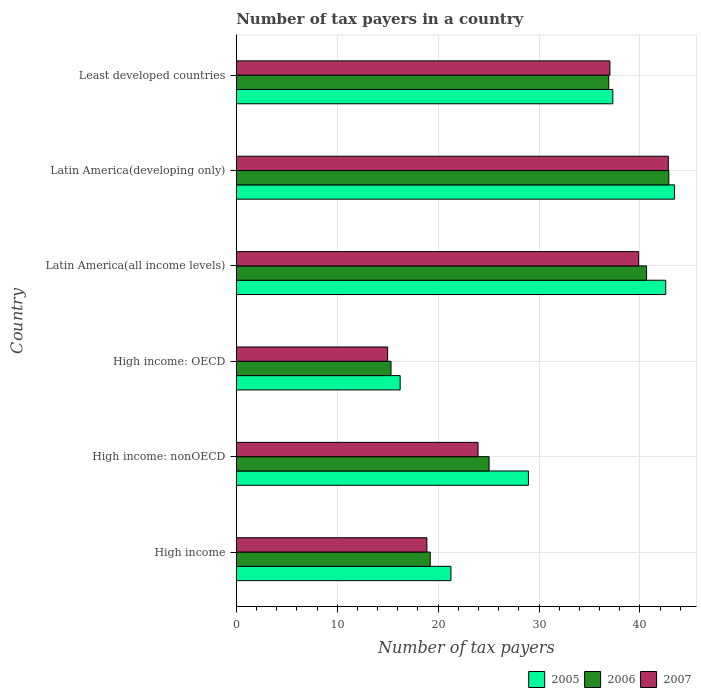How many groups of bars are there?
Make the answer very short. 6. Are the number of bars per tick equal to the number of legend labels?
Give a very brief answer. Yes. Are the number of bars on each tick of the Y-axis equal?
Your answer should be compact. Yes. What is the label of the 2nd group of bars from the top?
Your answer should be very brief. Latin America(developing only). In how many cases, is the number of bars for a given country not equal to the number of legend labels?
Provide a succinct answer. 0. What is the number of tax payers in in 2006 in High income: nonOECD?
Give a very brief answer. 25.05. Across all countries, what is the maximum number of tax payers in in 2005?
Provide a short and direct response. 43.43. Across all countries, what is the minimum number of tax payers in in 2005?
Provide a succinct answer. 16.24. In which country was the number of tax payers in in 2005 maximum?
Your answer should be compact. Latin America(developing only). In which country was the number of tax payers in in 2007 minimum?
Your answer should be very brief. High income: OECD. What is the total number of tax payers in in 2007 in the graph?
Ensure brevity in your answer.  177.54. What is the difference between the number of tax payers in in 2006 in High income: nonOECD and that in Latin America(all income levels)?
Make the answer very short. -15.61. What is the difference between the number of tax payers in in 2005 in Latin America(all income levels) and the number of tax payers in in 2006 in Least developed countries?
Your response must be concise. 5.64. What is the average number of tax payers in in 2006 per country?
Provide a short and direct response. 30. What is the difference between the number of tax payers in in 2005 and number of tax payers in in 2007 in High income: OECD?
Your answer should be very brief. 1.24. In how many countries, is the number of tax payers in in 2005 greater than 30 ?
Your answer should be very brief. 3. What is the ratio of the number of tax payers in in 2005 in High income to that in Least developed countries?
Ensure brevity in your answer.  0.57. What is the difference between the highest and the second highest number of tax payers in in 2005?
Offer a terse response. 0.88. What is the difference between the highest and the lowest number of tax payers in in 2006?
Keep it short and to the point. 27.52. Is the sum of the number of tax payers in in 2005 in High income and Latin America(all income levels) greater than the maximum number of tax payers in in 2007 across all countries?
Your answer should be compact. Yes. What does the 1st bar from the bottom in Latin America(all income levels) represents?
Offer a terse response. 2005. Is it the case that in every country, the sum of the number of tax payers in in 2006 and number of tax payers in in 2007 is greater than the number of tax payers in in 2005?
Make the answer very short. Yes. How many bars are there?
Keep it short and to the point. 18. Are all the bars in the graph horizontal?
Make the answer very short. Yes. How many countries are there in the graph?
Offer a very short reply. 6. Are the values on the major ticks of X-axis written in scientific E-notation?
Offer a very short reply. No. Where does the legend appear in the graph?
Give a very brief answer. Bottom right. How many legend labels are there?
Offer a terse response. 3. How are the legend labels stacked?
Make the answer very short. Horizontal. What is the title of the graph?
Give a very brief answer. Number of tax payers in a country. Does "1964" appear as one of the legend labels in the graph?
Provide a short and direct response. No. What is the label or title of the X-axis?
Offer a terse response. Number of tax payers. What is the Number of tax payers of 2005 in High income?
Your answer should be compact. 21.27. What is the Number of tax payers in 2006 in High income?
Your answer should be very brief. 19.22. What is the Number of tax payers of 2007 in High income?
Offer a terse response. 18.89. What is the Number of tax payers in 2005 in High income: nonOECD?
Offer a terse response. 28.95. What is the Number of tax payers of 2006 in High income: nonOECD?
Provide a short and direct response. 25.05. What is the Number of tax payers of 2007 in High income: nonOECD?
Make the answer very short. 23.96. What is the Number of tax payers of 2005 in High income: OECD?
Make the answer very short. 16.24. What is the Number of tax payers of 2006 in High income: OECD?
Your answer should be very brief. 15.33. What is the Number of tax payers of 2005 in Latin America(all income levels)?
Your answer should be very brief. 42.55. What is the Number of tax payers in 2006 in Latin America(all income levels)?
Ensure brevity in your answer.  40.66. What is the Number of tax payers of 2007 in Latin America(all income levels)?
Provide a short and direct response. 39.87. What is the Number of tax payers of 2005 in Latin America(developing only)?
Your answer should be very brief. 43.43. What is the Number of tax payers in 2006 in Latin America(developing only)?
Ensure brevity in your answer.  42.86. What is the Number of tax payers in 2007 in Latin America(developing only)?
Your answer should be compact. 42.81. What is the Number of tax payers in 2005 in Least developed countries?
Keep it short and to the point. 37.31. What is the Number of tax payers of 2006 in Least developed countries?
Offer a very short reply. 36.91. What is the Number of tax payers in 2007 in Least developed countries?
Offer a very short reply. 37.02. Across all countries, what is the maximum Number of tax payers in 2005?
Make the answer very short. 43.43. Across all countries, what is the maximum Number of tax payers in 2006?
Ensure brevity in your answer.  42.86. Across all countries, what is the maximum Number of tax payers in 2007?
Keep it short and to the point. 42.81. Across all countries, what is the minimum Number of tax payers in 2005?
Your answer should be compact. 16.24. Across all countries, what is the minimum Number of tax payers in 2006?
Your answer should be compact. 15.33. Across all countries, what is the minimum Number of tax payers of 2007?
Give a very brief answer. 15. What is the total Number of tax payers of 2005 in the graph?
Ensure brevity in your answer.  189.75. What is the total Number of tax payers in 2006 in the graph?
Offer a terse response. 180.02. What is the total Number of tax payers of 2007 in the graph?
Your answer should be very brief. 177.54. What is the difference between the Number of tax payers of 2005 in High income and that in High income: nonOECD?
Provide a succinct answer. -7.68. What is the difference between the Number of tax payers of 2006 in High income and that in High income: nonOECD?
Provide a succinct answer. -5.83. What is the difference between the Number of tax payers in 2007 in High income and that in High income: nonOECD?
Give a very brief answer. -5.07. What is the difference between the Number of tax payers of 2005 in High income and that in High income: OECD?
Ensure brevity in your answer.  5.03. What is the difference between the Number of tax payers in 2006 in High income and that in High income: OECD?
Your answer should be very brief. 3.89. What is the difference between the Number of tax payers of 2007 in High income and that in High income: OECD?
Give a very brief answer. 3.89. What is the difference between the Number of tax payers of 2005 in High income and that in Latin America(all income levels)?
Ensure brevity in your answer.  -21.28. What is the difference between the Number of tax payers in 2006 in High income and that in Latin America(all income levels)?
Offer a terse response. -21.44. What is the difference between the Number of tax payers in 2007 in High income and that in Latin America(all income levels)?
Your answer should be very brief. -20.98. What is the difference between the Number of tax payers of 2005 in High income and that in Latin America(developing only)?
Keep it short and to the point. -22.16. What is the difference between the Number of tax payers in 2006 in High income and that in Latin America(developing only)?
Your answer should be very brief. -23.64. What is the difference between the Number of tax payers of 2007 in High income and that in Latin America(developing only)?
Give a very brief answer. -23.92. What is the difference between the Number of tax payers of 2005 in High income and that in Least developed countries?
Keep it short and to the point. -16.04. What is the difference between the Number of tax payers in 2006 in High income and that in Least developed countries?
Provide a short and direct response. -17.69. What is the difference between the Number of tax payers in 2007 in High income and that in Least developed countries?
Keep it short and to the point. -18.14. What is the difference between the Number of tax payers of 2005 in High income: nonOECD and that in High income: OECD?
Offer a terse response. 12.71. What is the difference between the Number of tax payers of 2006 in High income: nonOECD and that in High income: OECD?
Your answer should be very brief. 9.72. What is the difference between the Number of tax payers of 2007 in High income: nonOECD and that in High income: OECD?
Your response must be concise. 8.96. What is the difference between the Number of tax payers in 2005 in High income: nonOECD and that in Latin America(all income levels)?
Keep it short and to the point. -13.6. What is the difference between the Number of tax payers of 2006 in High income: nonOECD and that in Latin America(all income levels)?
Provide a succinct answer. -15.61. What is the difference between the Number of tax payers of 2007 in High income: nonOECD and that in Latin America(all income levels)?
Provide a succinct answer. -15.91. What is the difference between the Number of tax payers in 2005 in High income: nonOECD and that in Latin America(developing only)?
Your response must be concise. -14.48. What is the difference between the Number of tax payers in 2006 in High income: nonOECD and that in Latin America(developing only)?
Make the answer very short. -17.81. What is the difference between the Number of tax payers in 2007 in High income: nonOECD and that in Latin America(developing only)?
Give a very brief answer. -18.85. What is the difference between the Number of tax payers of 2005 in High income: nonOECD and that in Least developed countries?
Offer a very short reply. -8.36. What is the difference between the Number of tax payers of 2006 in High income: nonOECD and that in Least developed countries?
Your answer should be compact. -11.86. What is the difference between the Number of tax payers in 2007 in High income: nonOECD and that in Least developed countries?
Give a very brief answer. -13.07. What is the difference between the Number of tax payers of 2005 in High income: OECD and that in Latin America(all income levels)?
Provide a succinct answer. -26.31. What is the difference between the Number of tax payers of 2006 in High income: OECD and that in Latin America(all income levels)?
Your response must be concise. -25.32. What is the difference between the Number of tax payers in 2007 in High income: OECD and that in Latin America(all income levels)?
Provide a succinct answer. -24.87. What is the difference between the Number of tax payers in 2005 in High income: OECD and that in Latin America(developing only)?
Ensure brevity in your answer.  -27.19. What is the difference between the Number of tax payers in 2006 in High income: OECD and that in Latin America(developing only)?
Your answer should be very brief. -27.52. What is the difference between the Number of tax payers of 2007 in High income: OECD and that in Latin America(developing only)?
Your response must be concise. -27.81. What is the difference between the Number of tax payers in 2005 in High income: OECD and that in Least developed countries?
Ensure brevity in your answer.  -21.07. What is the difference between the Number of tax payers of 2006 in High income: OECD and that in Least developed countries?
Offer a very short reply. -21.57. What is the difference between the Number of tax payers of 2007 in High income: OECD and that in Least developed countries?
Provide a succinct answer. -22.02. What is the difference between the Number of tax payers of 2005 in Latin America(all income levels) and that in Latin America(developing only)?
Offer a terse response. -0.88. What is the difference between the Number of tax payers of 2006 in Latin America(all income levels) and that in Latin America(developing only)?
Give a very brief answer. -2.2. What is the difference between the Number of tax payers of 2007 in Latin America(all income levels) and that in Latin America(developing only)?
Offer a terse response. -2.94. What is the difference between the Number of tax payers of 2005 in Latin America(all income levels) and that in Least developed countries?
Provide a short and direct response. 5.24. What is the difference between the Number of tax payers in 2006 in Latin America(all income levels) and that in Least developed countries?
Ensure brevity in your answer.  3.75. What is the difference between the Number of tax payers of 2007 in Latin America(all income levels) and that in Least developed countries?
Offer a very short reply. 2.84. What is the difference between the Number of tax payers of 2005 in Latin America(developing only) and that in Least developed countries?
Keep it short and to the point. 6.12. What is the difference between the Number of tax payers of 2006 in Latin America(developing only) and that in Least developed countries?
Provide a succinct answer. 5.95. What is the difference between the Number of tax payers in 2007 in Latin America(developing only) and that in Least developed countries?
Offer a terse response. 5.79. What is the difference between the Number of tax payers of 2005 in High income and the Number of tax payers of 2006 in High income: nonOECD?
Offer a terse response. -3.78. What is the difference between the Number of tax payers of 2005 in High income and the Number of tax payers of 2007 in High income: nonOECD?
Make the answer very short. -2.69. What is the difference between the Number of tax payers of 2006 in High income and the Number of tax payers of 2007 in High income: nonOECD?
Make the answer very short. -4.74. What is the difference between the Number of tax payers of 2005 in High income and the Number of tax payers of 2006 in High income: OECD?
Ensure brevity in your answer.  5.94. What is the difference between the Number of tax payers of 2005 in High income and the Number of tax payers of 2007 in High income: OECD?
Offer a terse response. 6.27. What is the difference between the Number of tax payers of 2006 in High income and the Number of tax payers of 2007 in High income: OECD?
Keep it short and to the point. 4.22. What is the difference between the Number of tax payers of 2005 in High income and the Number of tax payers of 2006 in Latin America(all income levels)?
Give a very brief answer. -19.38. What is the difference between the Number of tax payers of 2005 in High income and the Number of tax payers of 2007 in Latin America(all income levels)?
Provide a succinct answer. -18.6. What is the difference between the Number of tax payers of 2006 in High income and the Number of tax payers of 2007 in Latin America(all income levels)?
Keep it short and to the point. -20.65. What is the difference between the Number of tax payers of 2005 in High income and the Number of tax payers of 2006 in Latin America(developing only)?
Provide a succinct answer. -21.59. What is the difference between the Number of tax payers in 2005 in High income and the Number of tax payers in 2007 in Latin America(developing only)?
Your answer should be compact. -21.54. What is the difference between the Number of tax payers of 2006 in High income and the Number of tax payers of 2007 in Latin America(developing only)?
Provide a succinct answer. -23.59. What is the difference between the Number of tax payers in 2005 in High income and the Number of tax payers in 2006 in Least developed countries?
Make the answer very short. -15.64. What is the difference between the Number of tax payers of 2005 in High income and the Number of tax payers of 2007 in Least developed countries?
Keep it short and to the point. -15.75. What is the difference between the Number of tax payers in 2006 in High income and the Number of tax payers in 2007 in Least developed countries?
Your answer should be compact. -17.8. What is the difference between the Number of tax payers in 2005 in High income: nonOECD and the Number of tax payers in 2006 in High income: OECD?
Provide a short and direct response. 13.61. What is the difference between the Number of tax payers in 2005 in High income: nonOECD and the Number of tax payers in 2007 in High income: OECD?
Make the answer very short. 13.95. What is the difference between the Number of tax payers of 2006 in High income: nonOECD and the Number of tax payers of 2007 in High income: OECD?
Offer a terse response. 10.05. What is the difference between the Number of tax payers of 2005 in High income: nonOECD and the Number of tax payers of 2006 in Latin America(all income levels)?
Provide a short and direct response. -11.71. What is the difference between the Number of tax payers of 2005 in High income: nonOECD and the Number of tax payers of 2007 in Latin America(all income levels)?
Give a very brief answer. -10.92. What is the difference between the Number of tax payers in 2006 in High income: nonOECD and the Number of tax payers in 2007 in Latin America(all income levels)?
Offer a very short reply. -14.82. What is the difference between the Number of tax payers in 2005 in High income: nonOECD and the Number of tax payers in 2006 in Latin America(developing only)?
Ensure brevity in your answer.  -13.91. What is the difference between the Number of tax payers of 2005 in High income: nonOECD and the Number of tax payers of 2007 in Latin America(developing only)?
Offer a very short reply. -13.86. What is the difference between the Number of tax payers of 2006 in High income: nonOECD and the Number of tax payers of 2007 in Latin America(developing only)?
Make the answer very short. -17.76. What is the difference between the Number of tax payers in 2005 in High income: nonOECD and the Number of tax payers in 2006 in Least developed countries?
Provide a short and direct response. -7.96. What is the difference between the Number of tax payers of 2005 in High income: nonOECD and the Number of tax payers of 2007 in Least developed countries?
Provide a short and direct response. -8.08. What is the difference between the Number of tax payers in 2006 in High income: nonOECD and the Number of tax payers in 2007 in Least developed countries?
Your answer should be very brief. -11.97. What is the difference between the Number of tax payers in 2005 in High income: OECD and the Number of tax payers in 2006 in Latin America(all income levels)?
Ensure brevity in your answer.  -24.41. What is the difference between the Number of tax payers in 2005 in High income: OECD and the Number of tax payers in 2007 in Latin America(all income levels)?
Your answer should be compact. -23.63. What is the difference between the Number of tax payers in 2006 in High income: OECD and the Number of tax payers in 2007 in Latin America(all income levels)?
Make the answer very short. -24.53. What is the difference between the Number of tax payers of 2005 in High income: OECD and the Number of tax payers of 2006 in Latin America(developing only)?
Make the answer very short. -26.62. What is the difference between the Number of tax payers in 2005 in High income: OECD and the Number of tax payers in 2007 in Latin America(developing only)?
Keep it short and to the point. -26.57. What is the difference between the Number of tax payers of 2006 in High income: OECD and the Number of tax payers of 2007 in Latin America(developing only)?
Offer a very short reply. -27.48. What is the difference between the Number of tax payers in 2005 in High income: OECD and the Number of tax payers in 2006 in Least developed countries?
Your answer should be very brief. -20.67. What is the difference between the Number of tax payers in 2005 in High income: OECD and the Number of tax payers in 2007 in Least developed countries?
Provide a succinct answer. -20.78. What is the difference between the Number of tax payers in 2006 in High income: OECD and the Number of tax payers in 2007 in Least developed countries?
Give a very brief answer. -21.69. What is the difference between the Number of tax payers of 2005 in Latin America(all income levels) and the Number of tax payers of 2006 in Latin America(developing only)?
Offer a very short reply. -0.31. What is the difference between the Number of tax payers of 2005 in Latin America(all income levels) and the Number of tax payers of 2007 in Latin America(developing only)?
Provide a short and direct response. -0.26. What is the difference between the Number of tax payers of 2006 in Latin America(all income levels) and the Number of tax payers of 2007 in Latin America(developing only)?
Give a very brief answer. -2.15. What is the difference between the Number of tax payers of 2005 in Latin America(all income levels) and the Number of tax payers of 2006 in Least developed countries?
Your answer should be very brief. 5.64. What is the difference between the Number of tax payers of 2005 in Latin America(all income levels) and the Number of tax payers of 2007 in Least developed countries?
Your answer should be compact. 5.53. What is the difference between the Number of tax payers in 2006 in Latin America(all income levels) and the Number of tax payers in 2007 in Least developed countries?
Make the answer very short. 3.63. What is the difference between the Number of tax payers in 2005 in Latin America(developing only) and the Number of tax payers in 2006 in Least developed countries?
Give a very brief answer. 6.52. What is the difference between the Number of tax payers of 2005 in Latin America(developing only) and the Number of tax payers of 2007 in Least developed countries?
Make the answer very short. 6.41. What is the difference between the Number of tax payers in 2006 in Latin America(developing only) and the Number of tax payers in 2007 in Least developed countries?
Keep it short and to the point. 5.83. What is the average Number of tax payers of 2005 per country?
Give a very brief answer. 31.62. What is the average Number of tax payers in 2006 per country?
Ensure brevity in your answer.  30. What is the average Number of tax payers of 2007 per country?
Provide a succinct answer. 29.59. What is the difference between the Number of tax payers of 2005 and Number of tax payers of 2006 in High income?
Provide a succinct answer. 2.05. What is the difference between the Number of tax payers in 2005 and Number of tax payers in 2007 in High income?
Keep it short and to the point. 2.38. What is the difference between the Number of tax payers of 2006 and Number of tax payers of 2007 in High income?
Give a very brief answer. 0.33. What is the difference between the Number of tax payers in 2005 and Number of tax payers in 2006 in High income: nonOECD?
Your answer should be compact. 3.9. What is the difference between the Number of tax payers in 2005 and Number of tax payers in 2007 in High income: nonOECD?
Offer a terse response. 4.99. What is the difference between the Number of tax payers of 2006 and Number of tax payers of 2007 in High income: nonOECD?
Offer a very short reply. 1.09. What is the difference between the Number of tax payers of 2005 and Number of tax payers of 2006 in High income: OECD?
Ensure brevity in your answer.  0.91. What is the difference between the Number of tax payers of 2005 and Number of tax payers of 2007 in High income: OECD?
Offer a terse response. 1.24. What is the difference between the Number of tax payers in 2005 and Number of tax payers in 2006 in Latin America(all income levels)?
Keep it short and to the point. 1.9. What is the difference between the Number of tax payers of 2005 and Number of tax payers of 2007 in Latin America(all income levels)?
Provide a succinct answer. 2.69. What is the difference between the Number of tax payers in 2006 and Number of tax payers in 2007 in Latin America(all income levels)?
Keep it short and to the point. 0.79. What is the difference between the Number of tax payers in 2005 and Number of tax payers in 2006 in Latin America(developing only)?
Give a very brief answer. 0.57. What is the difference between the Number of tax payers of 2005 and Number of tax payers of 2007 in Latin America(developing only)?
Offer a very short reply. 0.62. What is the difference between the Number of tax payers in 2006 and Number of tax payers in 2007 in Latin America(developing only)?
Provide a succinct answer. 0.05. What is the difference between the Number of tax payers in 2005 and Number of tax payers in 2006 in Least developed countries?
Provide a short and direct response. 0.4. What is the difference between the Number of tax payers in 2005 and Number of tax payers in 2007 in Least developed countries?
Provide a short and direct response. 0.29. What is the difference between the Number of tax payers in 2006 and Number of tax payers in 2007 in Least developed countries?
Ensure brevity in your answer.  -0.12. What is the ratio of the Number of tax payers in 2005 in High income to that in High income: nonOECD?
Offer a terse response. 0.73. What is the ratio of the Number of tax payers in 2006 in High income to that in High income: nonOECD?
Provide a succinct answer. 0.77. What is the ratio of the Number of tax payers of 2007 in High income to that in High income: nonOECD?
Ensure brevity in your answer.  0.79. What is the ratio of the Number of tax payers in 2005 in High income to that in High income: OECD?
Give a very brief answer. 1.31. What is the ratio of the Number of tax payers of 2006 in High income to that in High income: OECD?
Provide a short and direct response. 1.25. What is the ratio of the Number of tax payers of 2007 in High income to that in High income: OECD?
Ensure brevity in your answer.  1.26. What is the ratio of the Number of tax payers of 2005 in High income to that in Latin America(all income levels)?
Your answer should be compact. 0.5. What is the ratio of the Number of tax payers in 2006 in High income to that in Latin America(all income levels)?
Offer a terse response. 0.47. What is the ratio of the Number of tax payers in 2007 in High income to that in Latin America(all income levels)?
Your answer should be compact. 0.47. What is the ratio of the Number of tax payers of 2005 in High income to that in Latin America(developing only)?
Offer a very short reply. 0.49. What is the ratio of the Number of tax payers of 2006 in High income to that in Latin America(developing only)?
Provide a succinct answer. 0.45. What is the ratio of the Number of tax payers in 2007 in High income to that in Latin America(developing only)?
Offer a terse response. 0.44. What is the ratio of the Number of tax payers in 2005 in High income to that in Least developed countries?
Your response must be concise. 0.57. What is the ratio of the Number of tax payers in 2006 in High income to that in Least developed countries?
Offer a very short reply. 0.52. What is the ratio of the Number of tax payers of 2007 in High income to that in Least developed countries?
Give a very brief answer. 0.51. What is the ratio of the Number of tax payers of 2005 in High income: nonOECD to that in High income: OECD?
Make the answer very short. 1.78. What is the ratio of the Number of tax payers in 2006 in High income: nonOECD to that in High income: OECD?
Ensure brevity in your answer.  1.63. What is the ratio of the Number of tax payers of 2007 in High income: nonOECD to that in High income: OECD?
Offer a terse response. 1.6. What is the ratio of the Number of tax payers in 2005 in High income: nonOECD to that in Latin America(all income levels)?
Give a very brief answer. 0.68. What is the ratio of the Number of tax payers in 2006 in High income: nonOECD to that in Latin America(all income levels)?
Give a very brief answer. 0.62. What is the ratio of the Number of tax payers in 2007 in High income: nonOECD to that in Latin America(all income levels)?
Give a very brief answer. 0.6. What is the ratio of the Number of tax payers in 2005 in High income: nonOECD to that in Latin America(developing only)?
Offer a terse response. 0.67. What is the ratio of the Number of tax payers of 2006 in High income: nonOECD to that in Latin America(developing only)?
Make the answer very short. 0.58. What is the ratio of the Number of tax payers in 2007 in High income: nonOECD to that in Latin America(developing only)?
Offer a very short reply. 0.56. What is the ratio of the Number of tax payers of 2005 in High income: nonOECD to that in Least developed countries?
Your response must be concise. 0.78. What is the ratio of the Number of tax payers in 2006 in High income: nonOECD to that in Least developed countries?
Your answer should be very brief. 0.68. What is the ratio of the Number of tax payers in 2007 in High income: nonOECD to that in Least developed countries?
Your response must be concise. 0.65. What is the ratio of the Number of tax payers of 2005 in High income: OECD to that in Latin America(all income levels)?
Offer a very short reply. 0.38. What is the ratio of the Number of tax payers of 2006 in High income: OECD to that in Latin America(all income levels)?
Your answer should be compact. 0.38. What is the ratio of the Number of tax payers of 2007 in High income: OECD to that in Latin America(all income levels)?
Keep it short and to the point. 0.38. What is the ratio of the Number of tax payers in 2005 in High income: OECD to that in Latin America(developing only)?
Provide a succinct answer. 0.37. What is the ratio of the Number of tax payers of 2006 in High income: OECD to that in Latin America(developing only)?
Offer a very short reply. 0.36. What is the ratio of the Number of tax payers in 2007 in High income: OECD to that in Latin America(developing only)?
Provide a short and direct response. 0.35. What is the ratio of the Number of tax payers in 2005 in High income: OECD to that in Least developed countries?
Offer a terse response. 0.44. What is the ratio of the Number of tax payers in 2006 in High income: OECD to that in Least developed countries?
Give a very brief answer. 0.42. What is the ratio of the Number of tax payers in 2007 in High income: OECD to that in Least developed countries?
Keep it short and to the point. 0.41. What is the ratio of the Number of tax payers of 2005 in Latin America(all income levels) to that in Latin America(developing only)?
Your answer should be compact. 0.98. What is the ratio of the Number of tax payers of 2006 in Latin America(all income levels) to that in Latin America(developing only)?
Offer a very short reply. 0.95. What is the ratio of the Number of tax payers in 2007 in Latin America(all income levels) to that in Latin America(developing only)?
Your response must be concise. 0.93. What is the ratio of the Number of tax payers of 2005 in Latin America(all income levels) to that in Least developed countries?
Offer a terse response. 1.14. What is the ratio of the Number of tax payers of 2006 in Latin America(all income levels) to that in Least developed countries?
Ensure brevity in your answer.  1.1. What is the ratio of the Number of tax payers in 2007 in Latin America(all income levels) to that in Least developed countries?
Your response must be concise. 1.08. What is the ratio of the Number of tax payers in 2005 in Latin America(developing only) to that in Least developed countries?
Keep it short and to the point. 1.16. What is the ratio of the Number of tax payers in 2006 in Latin America(developing only) to that in Least developed countries?
Give a very brief answer. 1.16. What is the ratio of the Number of tax payers of 2007 in Latin America(developing only) to that in Least developed countries?
Provide a short and direct response. 1.16. What is the difference between the highest and the second highest Number of tax payers in 2005?
Your answer should be compact. 0.88. What is the difference between the highest and the second highest Number of tax payers in 2006?
Keep it short and to the point. 2.2. What is the difference between the highest and the second highest Number of tax payers in 2007?
Your answer should be compact. 2.94. What is the difference between the highest and the lowest Number of tax payers of 2005?
Offer a very short reply. 27.19. What is the difference between the highest and the lowest Number of tax payers of 2006?
Ensure brevity in your answer.  27.52. What is the difference between the highest and the lowest Number of tax payers of 2007?
Offer a very short reply. 27.81. 